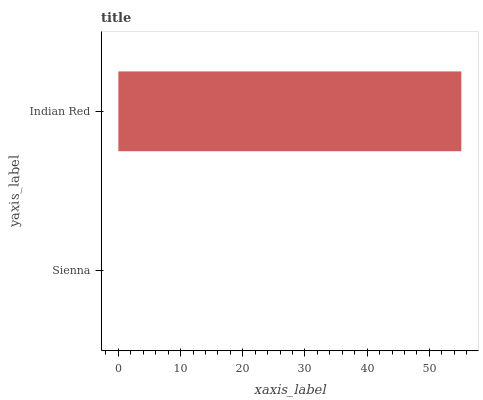Is Sienna the minimum?
Answer yes or no. Yes. Is Indian Red the maximum?
Answer yes or no. Yes. Is Indian Red the minimum?
Answer yes or no. No. Is Indian Red greater than Sienna?
Answer yes or no. Yes. Is Sienna less than Indian Red?
Answer yes or no. Yes. Is Sienna greater than Indian Red?
Answer yes or no. No. Is Indian Red less than Sienna?
Answer yes or no. No. Is Indian Red the high median?
Answer yes or no. Yes. Is Sienna the low median?
Answer yes or no. Yes. Is Sienna the high median?
Answer yes or no. No. Is Indian Red the low median?
Answer yes or no. No. 